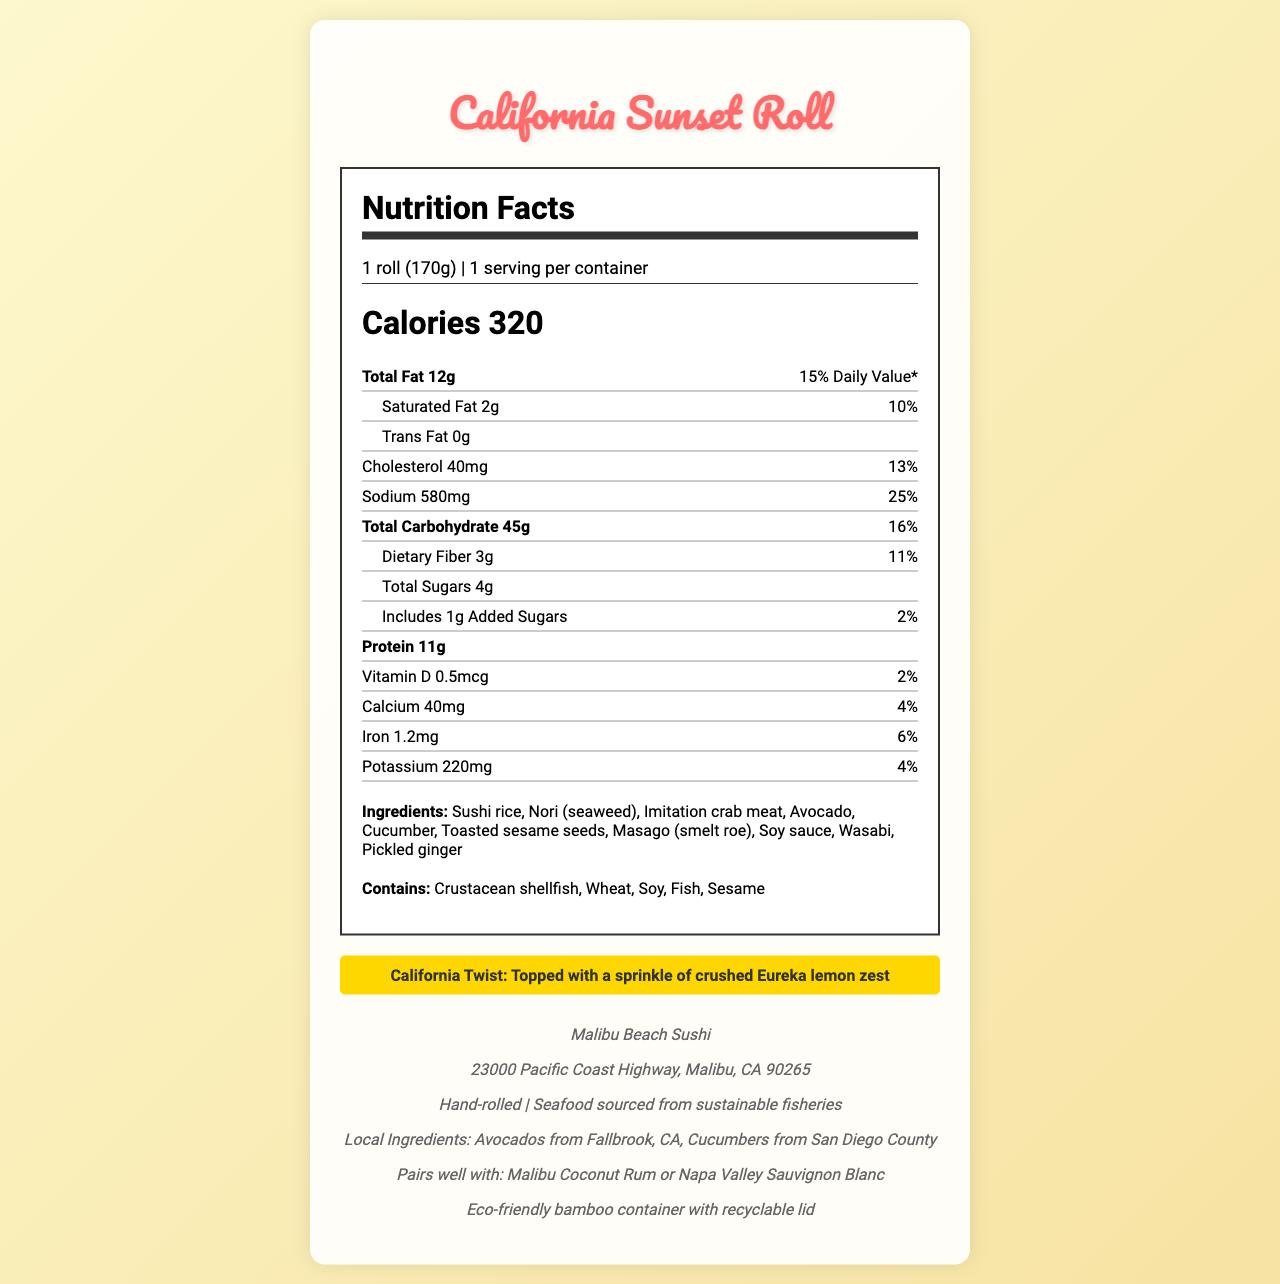what is the serving size of the California Sunset Roll? The serving size is stated as "1 roll (170g)" in the serving information section.
Answer: 1 roll (170g) how many grams of protein does the California Sunset Roll contain? The document lists the protein content as "11g".
Answer: 11g how many calories are there in one serving of the California Sunset Roll? The calories are indicated as "Calories 320" in the document.
Answer: 320 which restaurant makes the California Sunset Roll? The restaurant information section lists the restaurant name as "Malibu Beach Sushi."
Answer: Malibu Beach Sushi what is the daily value percentage of sodium in the California Sunset Roll? The sodium daily value percentage is listed as "25%" next to the sodium amount.
Answer: 25% how much added sugar is in the California Sunset Roll? The document specifies the added sugar content as "Includes 1g Added Sugars".
Answer: 1g what are two of the main ingredients in the roll? A. Salmon and Cream Cheese B. Imitation Crab Meat and Avocado C. Tuna and Tempura The ingredients list includes "Imitation crab meat" and "Avocado."
Answer: B what is the daily value percentage of saturated fat in the California Sunset Roll? A. 8% B. 10% C. 15% D. 20% The daily value for saturated fat is shown as "10%" in the saturated fat section.
Answer: B does the California Sunset Roll contain sesame? One of the allergens listed is "Sesame," indicating that the roll contains sesame.
Answer: Yes is the seafood used in the California Sunset Roll sourced from sustainable fisheries? The sustainability info states "Seafood sourced from sustainable fisheries."
Answer: Yes describe the main highlights of the California Sunset Roll nutrition and additional info. This summary includes the main nutritional facts such as calories, fats, carbohydrates, sodium, proteins, and added sugars. Additionally, it mentions the restaurant's name, location, sustainability practices, and packaging highlights.
Answer: The California Sunset Roll has 320 calories per serving. It contains 12g of total fat, 2g of saturated fat, 0g of trans fat, 40mg of cholesterol, and 580mg of sodium. It also has 45g of total carbohydrates, including 3g of dietary fiber and 4g of total sugars (1g added sugar). It provides 11g of protein. The roll is made by Malibu Beach Sushi, located in Malibu, CA, and is crafted with local ingredients such as avocados and cucumbers from CA. The seafood is sustainably sourced, and it comes in beach-friendly packaging. what is the main type of allergen found in ingredients? The document lists various allergens but doesn't specify which one is the main type found in the ingredients.
Answer: Cannot be determined how many servings are there per container? The serving information section mentions "1 serving per container."
Answer: 1 